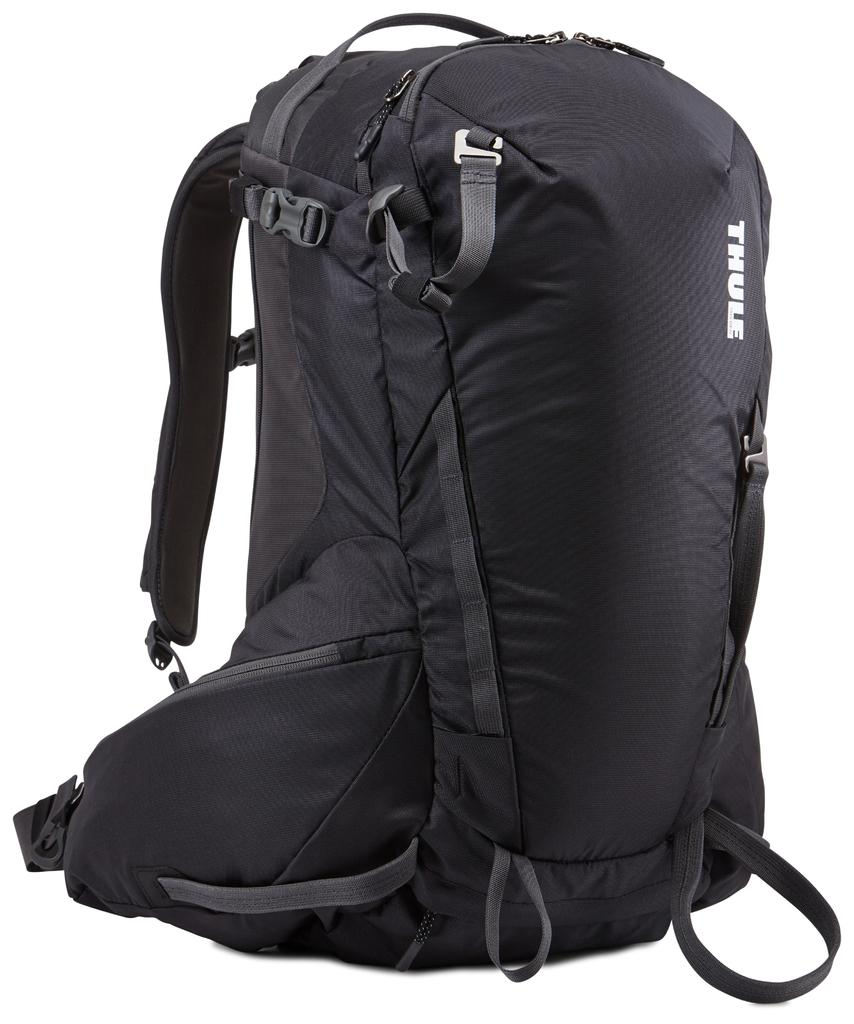What is the color of the bag in the image? The bag is black in color. How many zips are on the bag? The bag has multiple zips. What is written on the bag? The name 'THUE' is written on the bag. What is the color of the background in the image? The background is white. What type of texture can be felt on the bag in the image? The image does not provide information about the texture of the bag, so it cannot be determined from the image. 